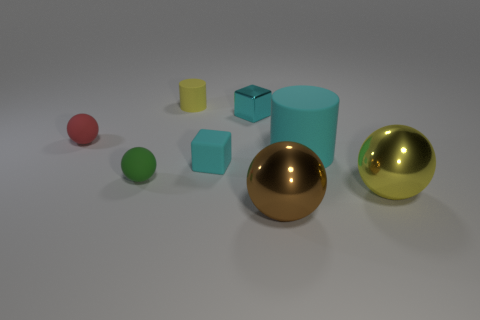Subtract 1 spheres. How many spheres are left? 3 Add 2 metallic things. How many objects exist? 10 Subtract all cylinders. How many objects are left? 6 Add 6 cyan rubber cubes. How many cyan rubber cubes exist? 7 Subtract 0 gray cubes. How many objects are left? 8 Subtract all brown metal things. Subtract all tiny yellow rubber cylinders. How many objects are left? 6 Add 3 matte blocks. How many matte blocks are left? 4 